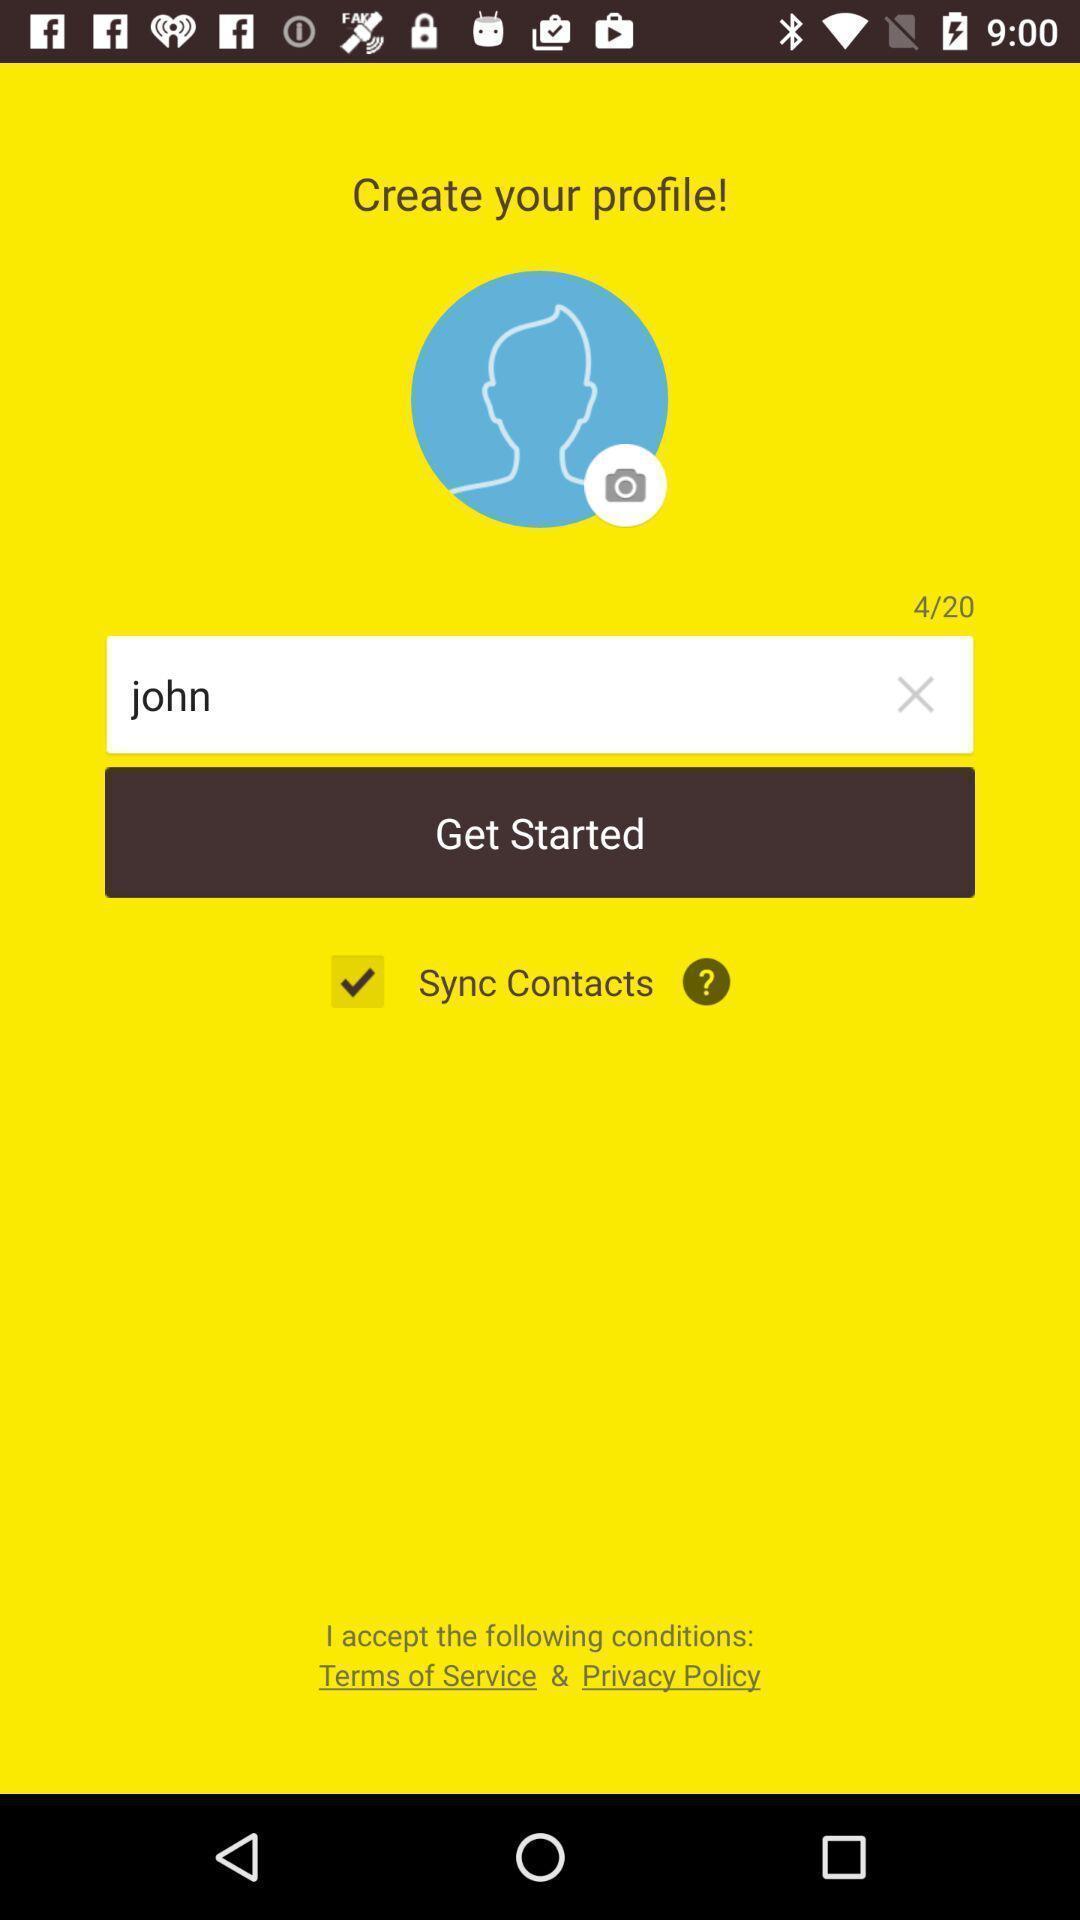Summarize the main components in this picture. Window displaying an messaging app. 